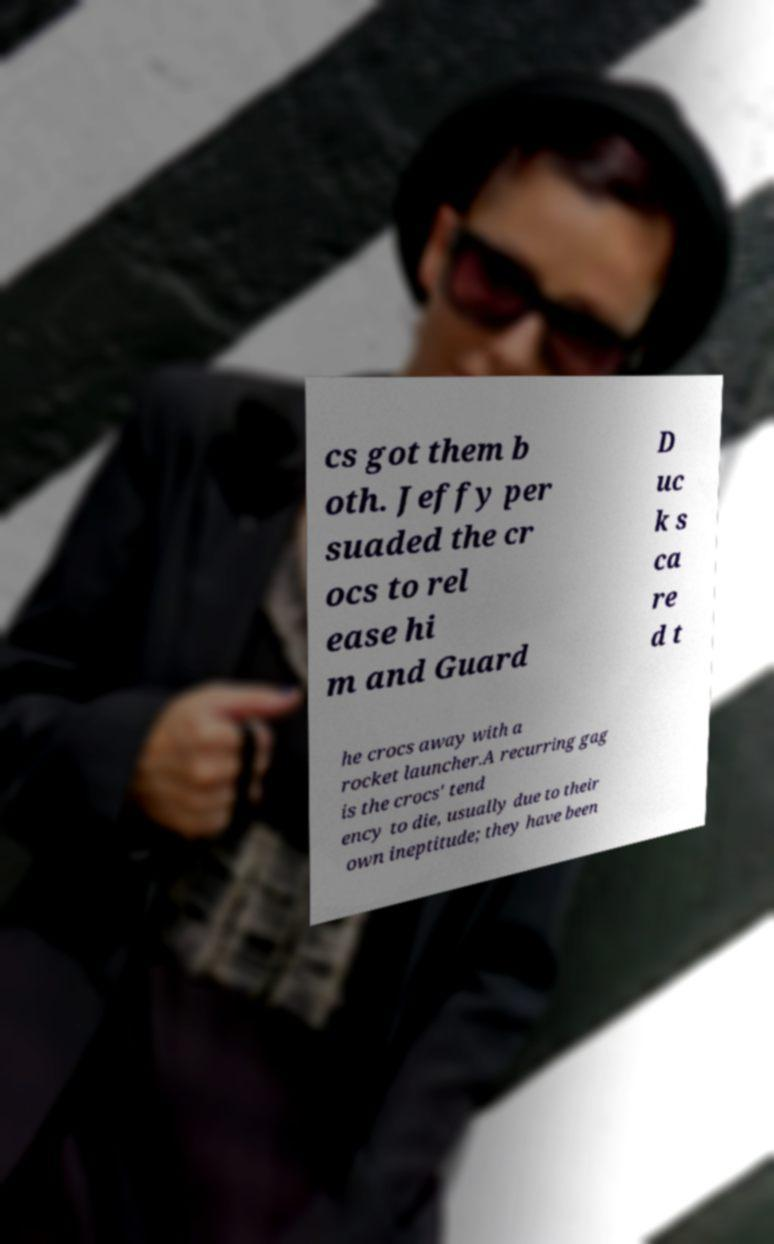There's text embedded in this image that I need extracted. Can you transcribe it verbatim? cs got them b oth. Jeffy per suaded the cr ocs to rel ease hi m and Guard D uc k s ca re d t he crocs away with a rocket launcher.A recurring gag is the crocs' tend ency to die, usually due to their own ineptitude; they have been 